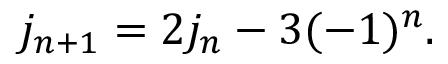<formula> <loc_0><loc_0><loc_500><loc_500>j _ { n + 1 } = 2 j _ { n } - 3 ( - 1 ) ^ { n } .</formula> 